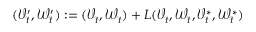Convert formula to latex. <formula><loc_0><loc_0><loc_500><loc_500>( \mathcal { V } _ { t } ^ { \prime } , \mathcal { W } _ { t } ^ { \prime } ) \colon = ( \mathcal { V } _ { t } , \mathcal { W } _ { t } ) + L ( \mathcal { V } _ { t } , \mathcal { W } _ { t } , \mathcal { V } _ { t } ^ { * } , \mathcal { W } _ { t } ^ { * } )</formula> 